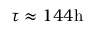<formula> <loc_0><loc_0><loc_500><loc_500>\tau \approx 1 4 4 h</formula> 